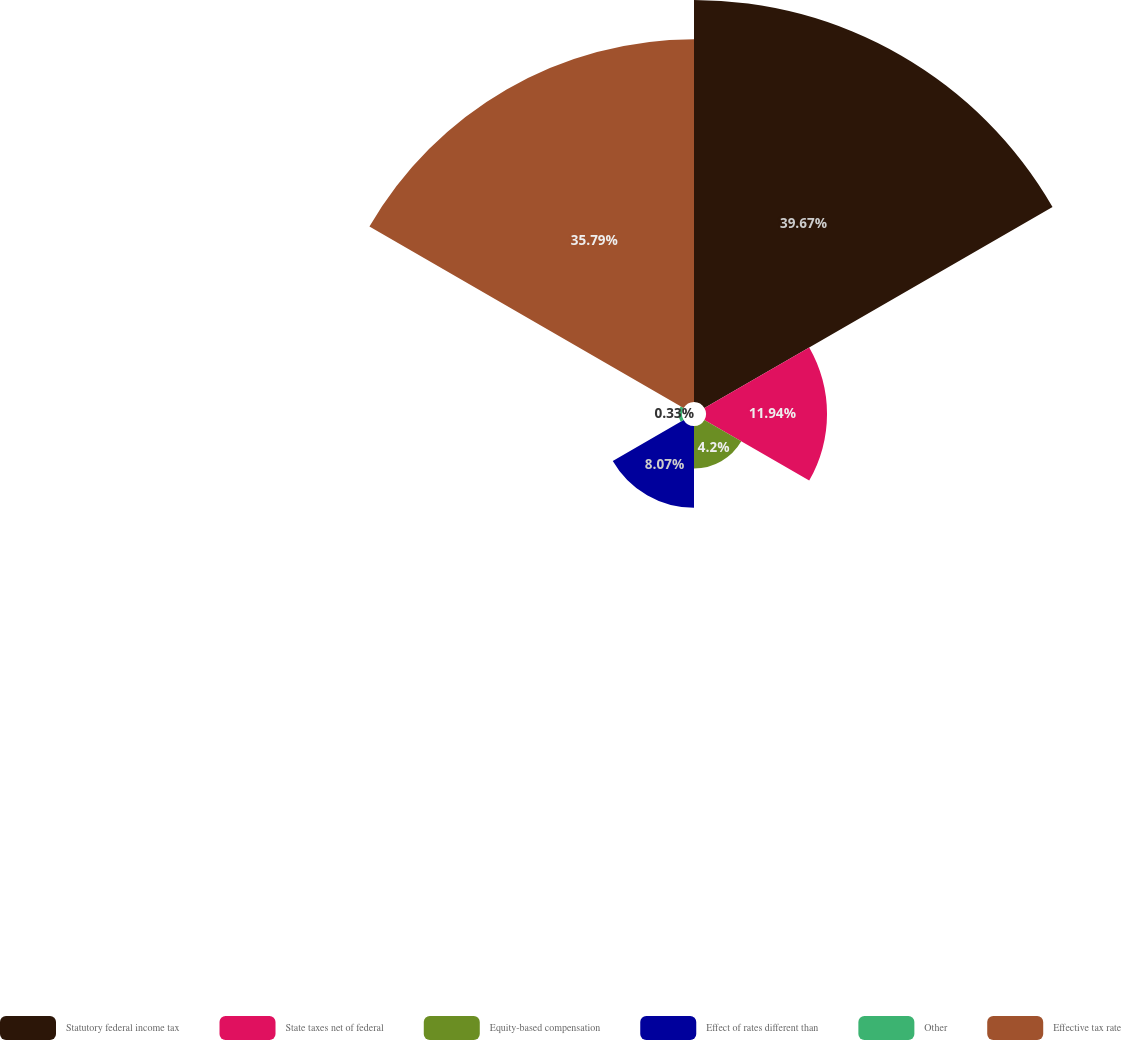<chart> <loc_0><loc_0><loc_500><loc_500><pie_chart><fcel>Statutory federal income tax<fcel>State taxes net of federal<fcel>Equity-based compensation<fcel>Effect of rates different than<fcel>Other<fcel>Effective tax rate<nl><fcel>39.66%<fcel>11.94%<fcel>4.2%<fcel>8.07%<fcel>0.33%<fcel>35.79%<nl></chart> 